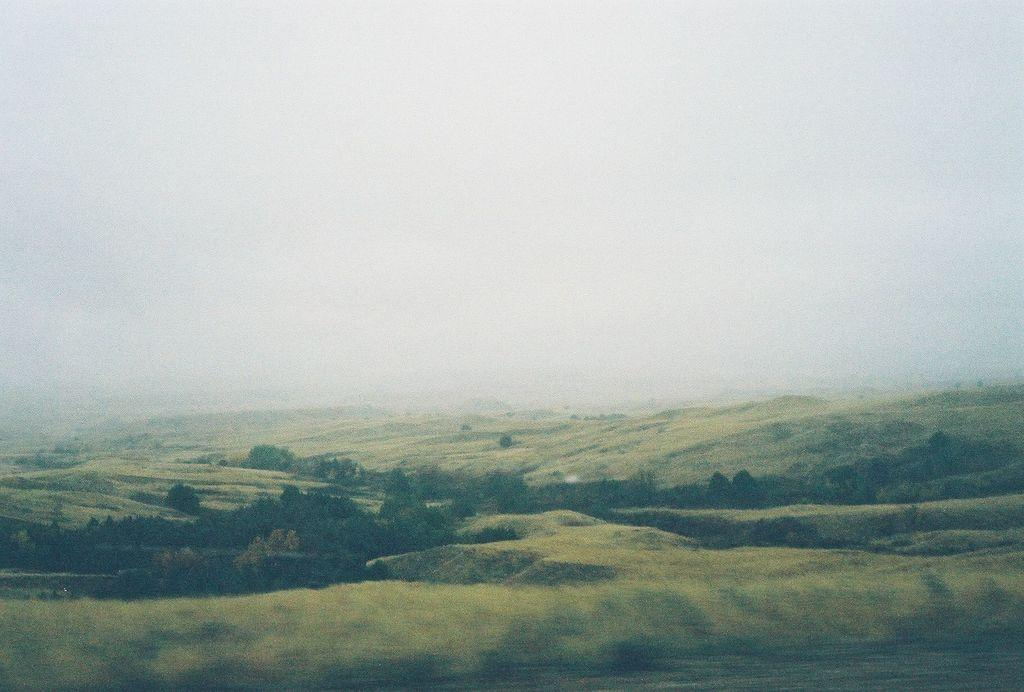What type of scenery is shown in the image? The image depicts a beautiful scenery. What kind of vegetation can be seen in the image? There are plenty of trees in the image. What is covering the ground in the image? There is grass on the surface in the image. How would you describe the background of the image? The background of the image is blurry. What is the level of disgust in the image? There is no indication of disgust in the image; it depicts a beautiful scenery with plenty of trees and grass. Can you tell me how many flights are visible in the image? There are no flights present in the image; it focuses on a beautiful scenery with trees, grass, and a blurry background. 